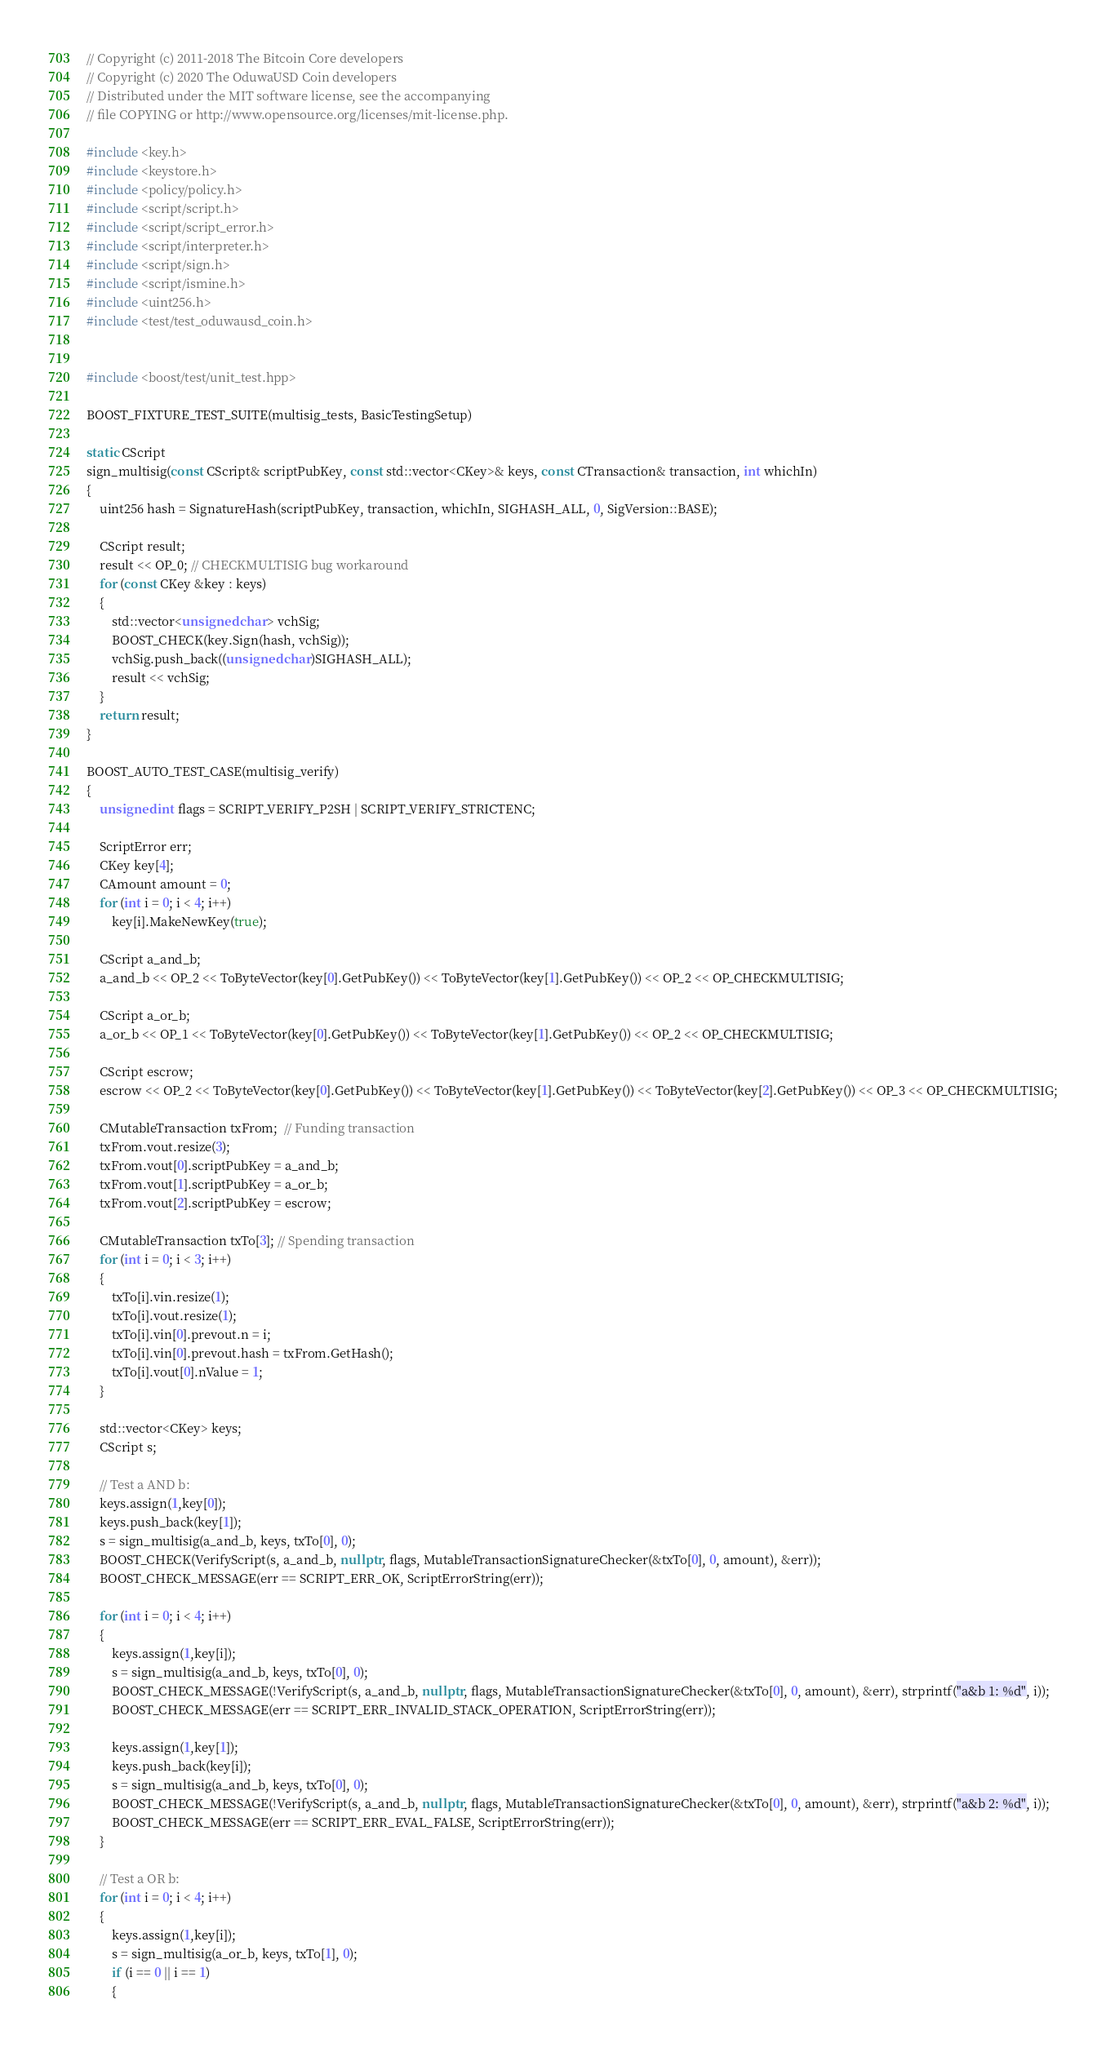<code> <loc_0><loc_0><loc_500><loc_500><_C++_>// Copyright (c) 2011-2018 The Bitcoin Core developers
// Copyright (c) 2020 The OduwaUSD Coin developers
// Distributed under the MIT software license, see the accompanying
// file COPYING or http://www.opensource.org/licenses/mit-license.php.

#include <key.h>
#include <keystore.h>
#include <policy/policy.h>
#include <script/script.h>
#include <script/script_error.h>
#include <script/interpreter.h>
#include <script/sign.h>
#include <script/ismine.h>
#include <uint256.h>
#include <test/test_oduwausd_coin.h>


#include <boost/test/unit_test.hpp>

BOOST_FIXTURE_TEST_SUITE(multisig_tests, BasicTestingSetup)

static CScript
sign_multisig(const CScript& scriptPubKey, const std::vector<CKey>& keys, const CTransaction& transaction, int whichIn)
{
    uint256 hash = SignatureHash(scriptPubKey, transaction, whichIn, SIGHASH_ALL, 0, SigVersion::BASE);

    CScript result;
    result << OP_0; // CHECKMULTISIG bug workaround
    for (const CKey &key : keys)
    {
        std::vector<unsigned char> vchSig;
        BOOST_CHECK(key.Sign(hash, vchSig));
        vchSig.push_back((unsigned char)SIGHASH_ALL);
        result << vchSig;
    }
    return result;
}

BOOST_AUTO_TEST_CASE(multisig_verify)
{
    unsigned int flags = SCRIPT_VERIFY_P2SH | SCRIPT_VERIFY_STRICTENC;

    ScriptError err;
    CKey key[4];
    CAmount amount = 0;
    for (int i = 0; i < 4; i++)
        key[i].MakeNewKey(true);

    CScript a_and_b;
    a_and_b << OP_2 << ToByteVector(key[0].GetPubKey()) << ToByteVector(key[1].GetPubKey()) << OP_2 << OP_CHECKMULTISIG;

    CScript a_or_b;
    a_or_b << OP_1 << ToByteVector(key[0].GetPubKey()) << ToByteVector(key[1].GetPubKey()) << OP_2 << OP_CHECKMULTISIG;

    CScript escrow;
    escrow << OP_2 << ToByteVector(key[0].GetPubKey()) << ToByteVector(key[1].GetPubKey()) << ToByteVector(key[2].GetPubKey()) << OP_3 << OP_CHECKMULTISIG;

    CMutableTransaction txFrom;  // Funding transaction
    txFrom.vout.resize(3);
    txFrom.vout[0].scriptPubKey = a_and_b;
    txFrom.vout[1].scriptPubKey = a_or_b;
    txFrom.vout[2].scriptPubKey = escrow;

    CMutableTransaction txTo[3]; // Spending transaction
    for (int i = 0; i < 3; i++)
    {
        txTo[i].vin.resize(1);
        txTo[i].vout.resize(1);
        txTo[i].vin[0].prevout.n = i;
        txTo[i].vin[0].prevout.hash = txFrom.GetHash();
        txTo[i].vout[0].nValue = 1;
    }

    std::vector<CKey> keys;
    CScript s;

    // Test a AND b:
    keys.assign(1,key[0]);
    keys.push_back(key[1]);
    s = sign_multisig(a_and_b, keys, txTo[0], 0);
    BOOST_CHECK(VerifyScript(s, a_and_b, nullptr, flags, MutableTransactionSignatureChecker(&txTo[0], 0, amount), &err));
    BOOST_CHECK_MESSAGE(err == SCRIPT_ERR_OK, ScriptErrorString(err));

    for (int i = 0; i < 4; i++)
    {
        keys.assign(1,key[i]);
        s = sign_multisig(a_and_b, keys, txTo[0], 0);
        BOOST_CHECK_MESSAGE(!VerifyScript(s, a_and_b, nullptr, flags, MutableTransactionSignatureChecker(&txTo[0], 0, amount), &err), strprintf("a&b 1: %d", i));
        BOOST_CHECK_MESSAGE(err == SCRIPT_ERR_INVALID_STACK_OPERATION, ScriptErrorString(err));

        keys.assign(1,key[1]);
        keys.push_back(key[i]);
        s = sign_multisig(a_and_b, keys, txTo[0], 0);
        BOOST_CHECK_MESSAGE(!VerifyScript(s, a_and_b, nullptr, flags, MutableTransactionSignatureChecker(&txTo[0], 0, amount), &err), strprintf("a&b 2: %d", i));
        BOOST_CHECK_MESSAGE(err == SCRIPT_ERR_EVAL_FALSE, ScriptErrorString(err));
    }

    // Test a OR b:
    for (int i = 0; i < 4; i++)
    {
        keys.assign(1,key[i]);
        s = sign_multisig(a_or_b, keys, txTo[1], 0);
        if (i == 0 || i == 1)
        {</code> 